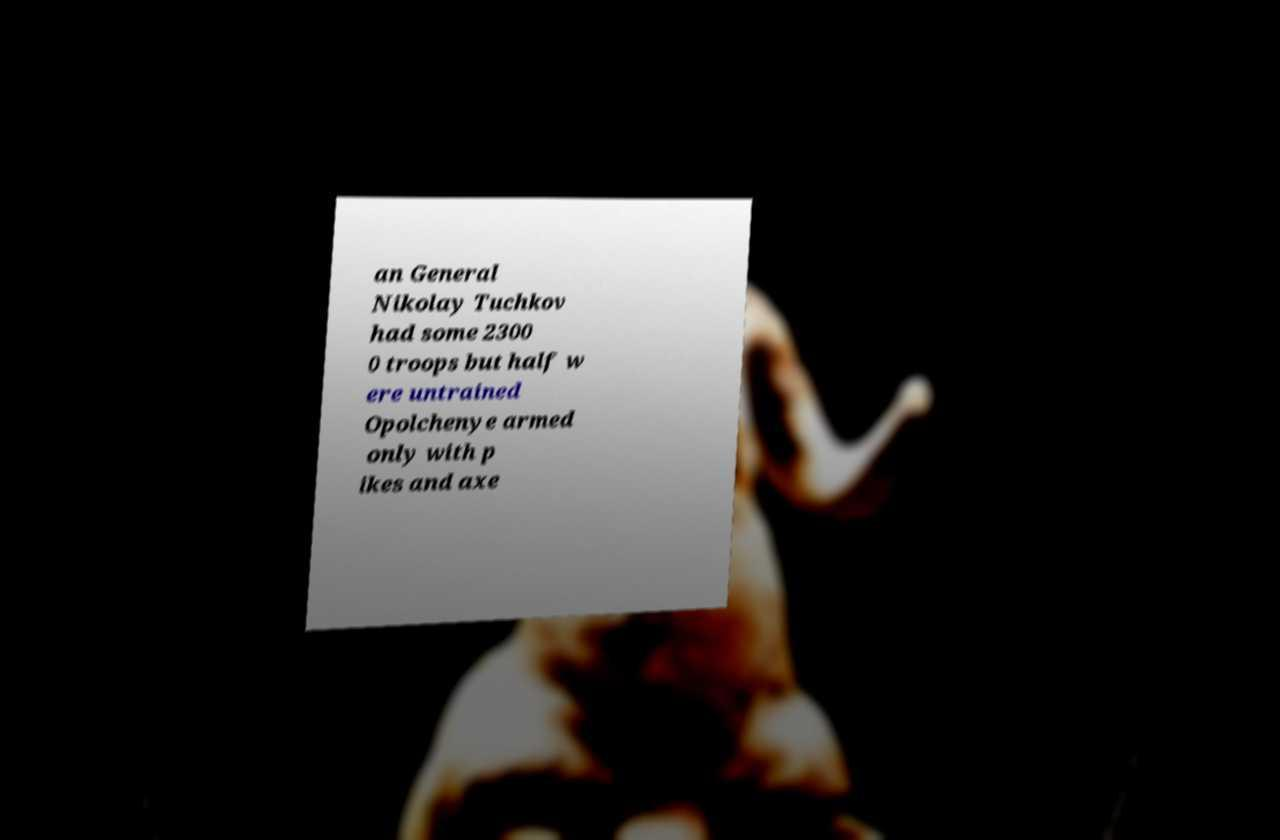There's text embedded in this image that I need extracted. Can you transcribe it verbatim? an General Nikolay Tuchkov had some 2300 0 troops but half w ere untrained Opolchenye armed only with p ikes and axe 